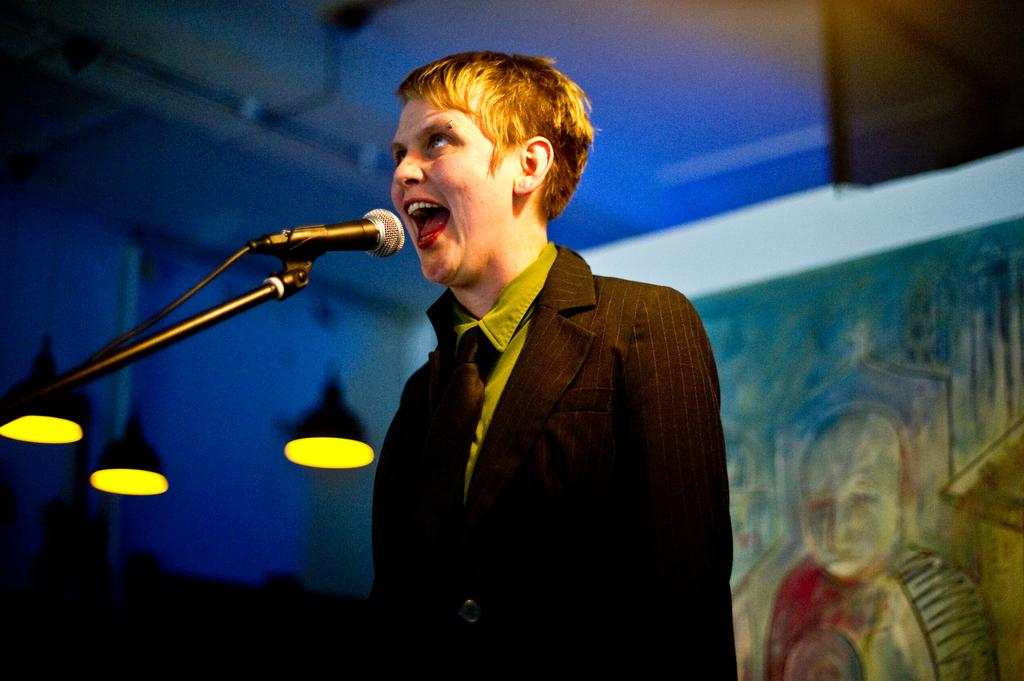What is the main subject of the image? There is a person in the image. What object is visible near the person? There is a microphone with a stand in the image. What can be seen in the background of the image? The background of the image is blurred. Are there any additional elements in the image? Yes, there are lights visible in the image. What type of potato is being used as a prop in the image? There is no potato present in the image. What is the person's interest in the image? The provided facts do not give any information about the person's interests, so we cannot answer this question. 